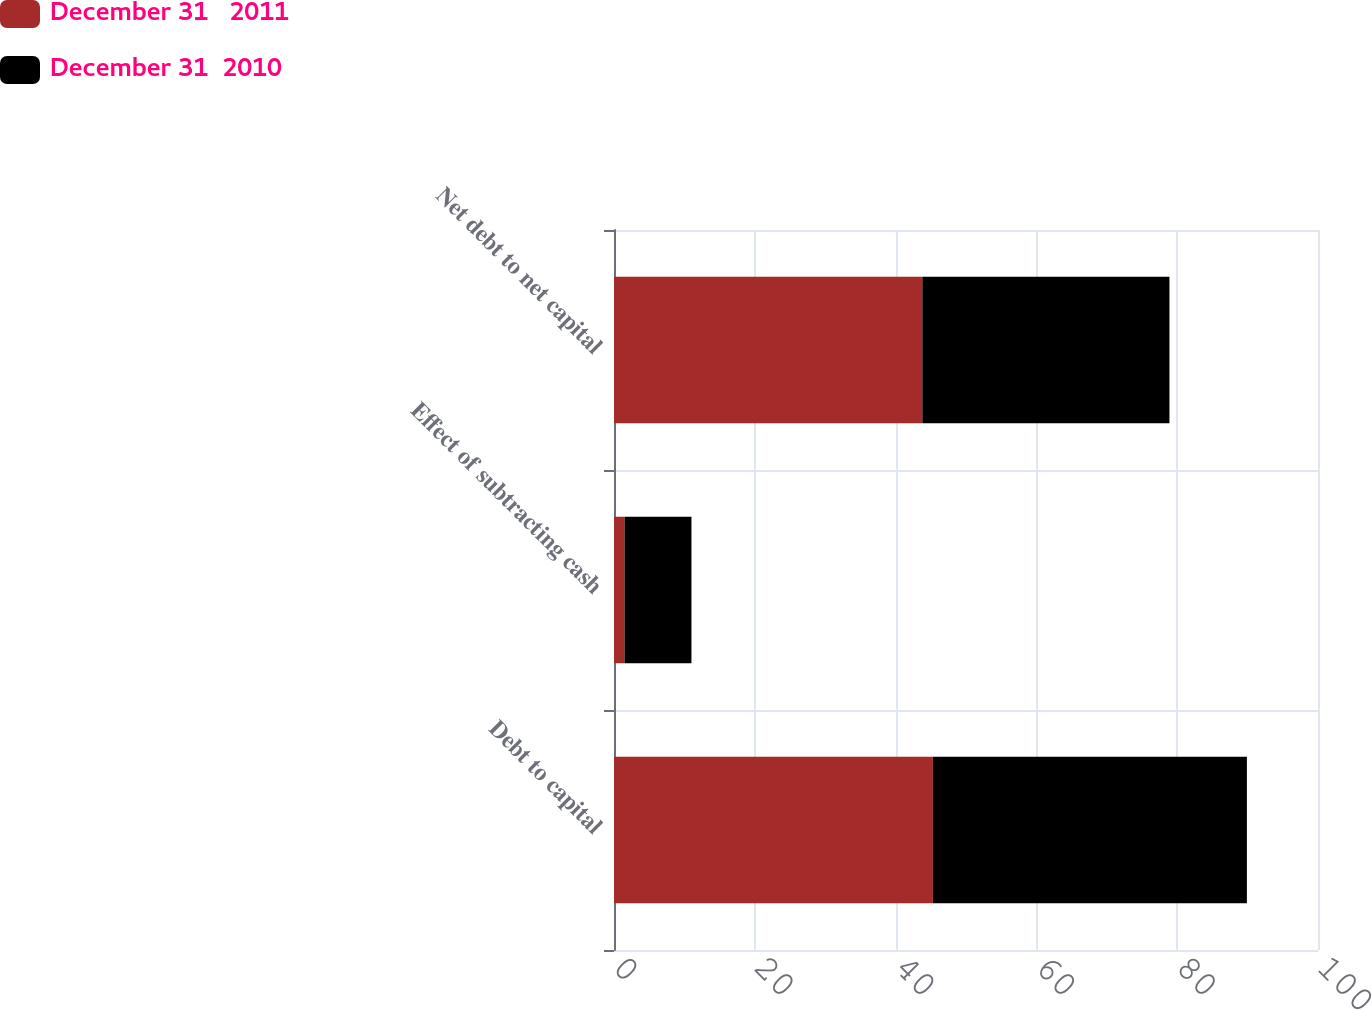Convert chart to OTSL. <chart><loc_0><loc_0><loc_500><loc_500><stacked_bar_chart><ecel><fcel>Debt to capital<fcel>Effect of subtracting cash<fcel>Net debt to net capital<nl><fcel>December 31   2011<fcel>45.3<fcel>1.5<fcel>43.8<nl><fcel>December 31  2010<fcel>44.6<fcel>9.5<fcel>35.1<nl></chart> 